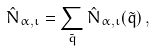<formula> <loc_0><loc_0><loc_500><loc_500>\hat { N } _ { \alpha , \iota } = \sum _ { \tilde { q } } \hat { N } _ { \alpha , \iota } ( \tilde { q } ) \, ,</formula> 